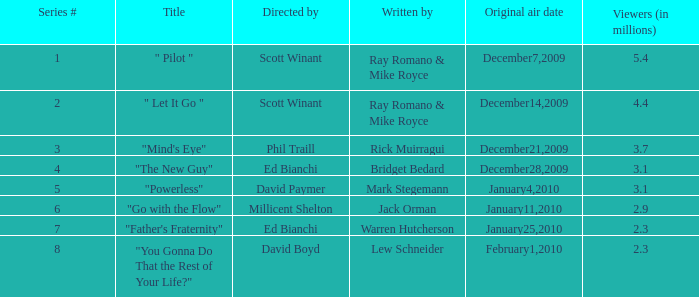What is the episode number of "you gonna do that for the rest of your existence?" 8.0. 